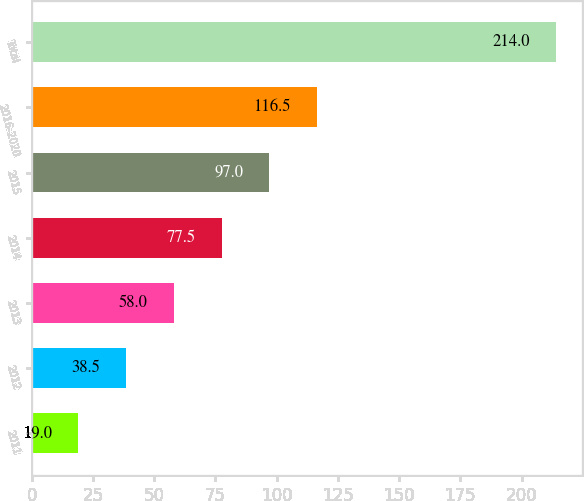Convert chart. <chart><loc_0><loc_0><loc_500><loc_500><bar_chart><fcel>2011<fcel>2012<fcel>2013<fcel>2014<fcel>2015<fcel>2016-2020<fcel>Total<nl><fcel>19<fcel>38.5<fcel>58<fcel>77.5<fcel>97<fcel>116.5<fcel>214<nl></chart> 